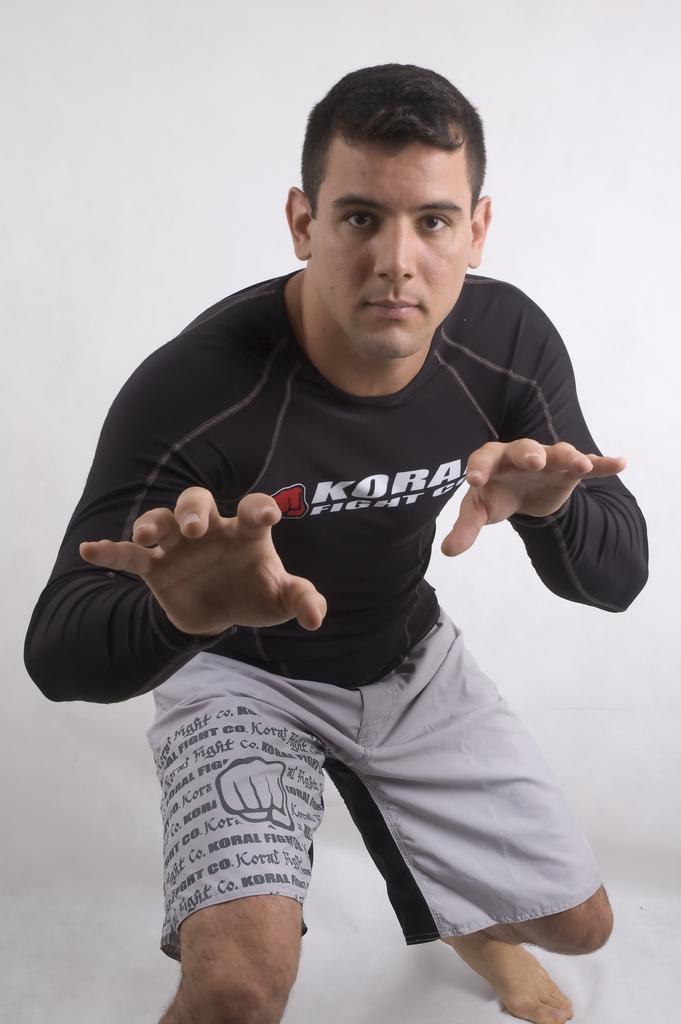Describe this image in one or two sentences. In this image we can see a man. He is wearing black color T-shirt with grey shorts. The background is white in color. 